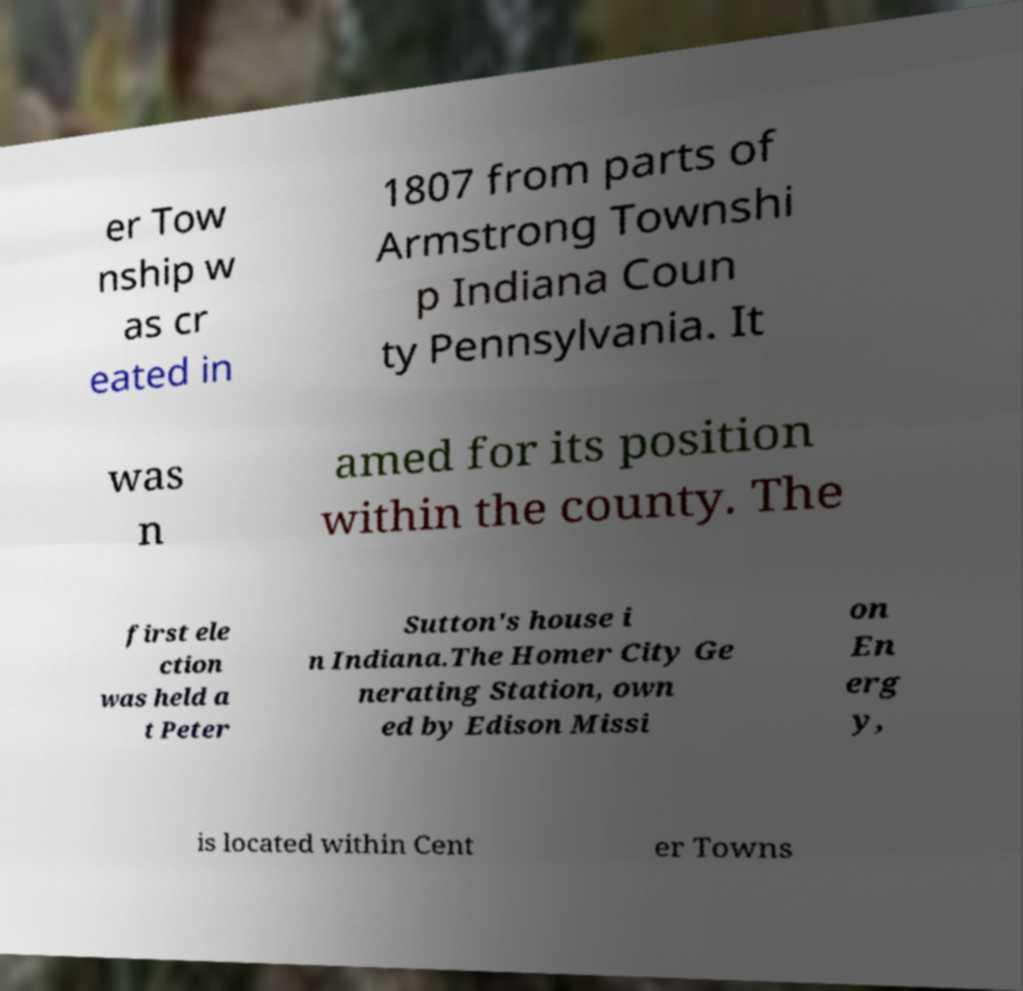I need the written content from this picture converted into text. Can you do that? er Tow nship w as cr eated in 1807 from parts of Armstrong Townshi p Indiana Coun ty Pennsylvania. It was n amed for its position within the county. The first ele ction was held a t Peter Sutton's house i n Indiana.The Homer City Ge nerating Station, own ed by Edison Missi on En erg y, is located within Cent er Towns 